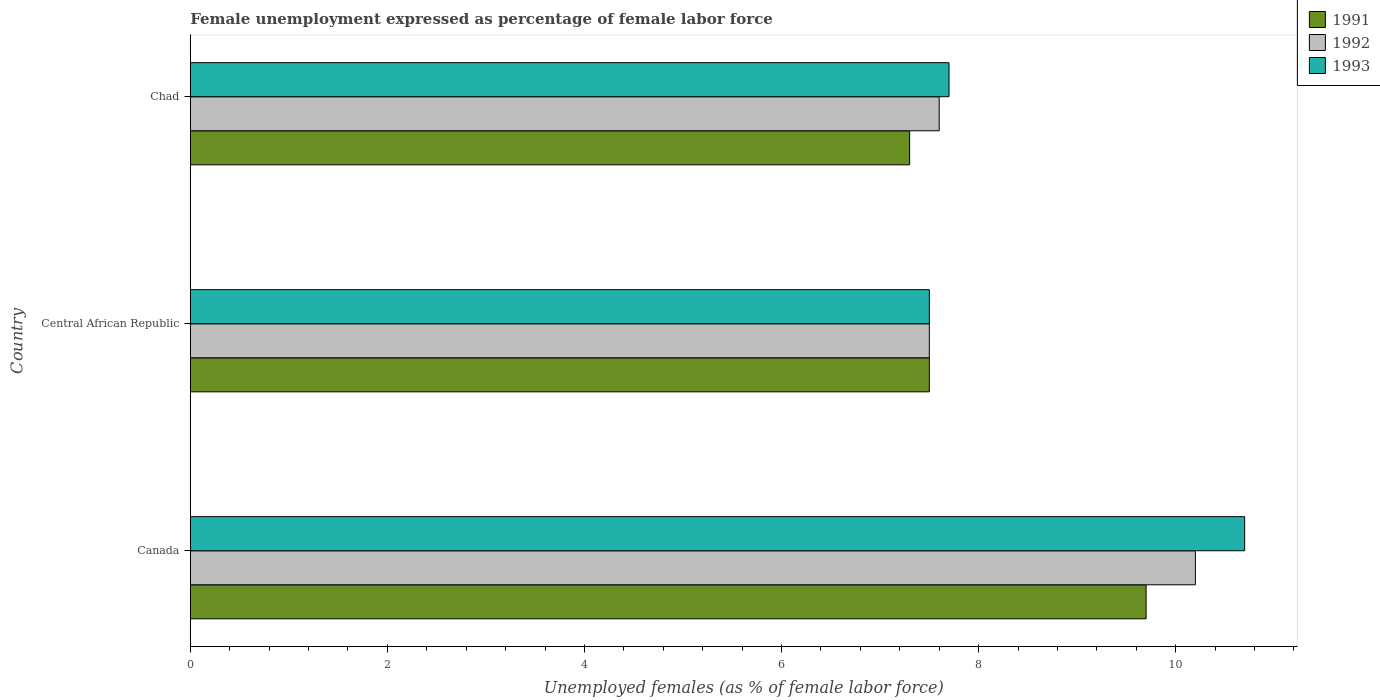How many groups of bars are there?
Give a very brief answer. 3. In how many cases, is the number of bars for a given country not equal to the number of legend labels?
Your response must be concise. 0. What is the unemployment in females in in 1993 in Central African Republic?
Your response must be concise. 7.5. Across all countries, what is the maximum unemployment in females in in 1993?
Provide a succinct answer. 10.7. In which country was the unemployment in females in in 1993 maximum?
Offer a terse response. Canada. In which country was the unemployment in females in in 1991 minimum?
Make the answer very short. Chad. What is the total unemployment in females in in 1993 in the graph?
Your response must be concise. 25.9. What is the difference between the unemployment in females in in 1993 in Central African Republic and that in Chad?
Make the answer very short. -0.2. What is the difference between the unemployment in females in in 1993 in Canada and the unemployment in females in in 1992 in Chad?
Your answer should be very brief. 3.1. What is the average unemployment in females in in 1992 per country?
Give a very brief answer. 8.43. What is the difference between the unemployment in females in in 1993 and unemployment in females in in 1992 in Canada?
Your answer should be very brief. 0.5. What is the ratio of the unemployment in females in in 1993 in Canada to that in Central African Republic?
Give a very brief answer. 1.43. Is the unemployment in females in in 1993 in Canada less than that in Central African Republic?
Provide a short and direct response. No. What is the difference between the highest and the second highest unemployment in females in in 1991?
Your answer should be very brief. 2.2. What is the difference between the highest and the lowest unemployment in females in in 1993?
Your response must be concise. 3.2. In how many countries, is the unemployment in females in in 1993 greater than the average unemployment in females in in 1993 taken over all countries?
Provide a short and direct response. 1. Is the sum of the unemployment in females in in 1993 in Central African Republic and Chad greater than the maximum unemployment in females in in 1991 across all countries?
Make the answer very short. Yes. What does the 1st bar from the top in Central African Republic represents?
Ensure brevity in your answer.  1993. What is the difference between two consecutive major ticks on the X-axis?
Keep it short and to the point. 2. Does the graph contain any zero values?
Keep it short and to the point. No. How are the legend labels stacked?
Give a very brief answer. Vertical. What is the title of the graph?
Your response must be concise. Female unemployment expressed as percentage of female labor force. What is the label or title of the X-axis?
Offer a very short reply. Unemployed females (as % of female labor force). What is the Unemployed females (as % of female labor force) of 1991 in Canada?
Make the answer very short. 9.7. What is the Unemployed females (as % of female labor force) in 1992 in Canada?
Provide a succinct answer. 10.2. What is the Unemployed females (as % of female labor force) in 1993 in Canada?
Ensure brevity in your answer.  10.7. What is the Unemployed females (as % of female labor force) in 1991 in Central African Republic?
Provide a short and direct response. 7.5. What is the Unemployed females (as % of female labor force) in 1992 in Central African Republic?
Offer a very short reply. 7.5. What is the Unemployed females (as % of female labor force) in 1993 in Central African Republic?
Provide a short and direct response. 7.5. What is the Unemployed females (as % of female labor force) in 1991 in Chad?
Ensure brevity in your answer.  7.3. What is the Unemployed females (as % of female labor force) in 1992 in Chad?
Offer a very short reply. 7.6. What is the Unemployed females (as % of female labor force) of 1993 in Chad?
Offer a terse response. 7.7. Across all countries, what is the maximum Unemployed females (as % of female labor force) of 1991?
Offer a very short reply. 9.7. Across all countries, what is the maximum Unemployed females (as % of female labor force) in 1992?
Your answer should be very brief. 10.2. Across all countries, what is the maximum Unemployed females (as % of female labor force) in 1993?
Ensure brevity in your answer.  10.7. Across all countries, what is the minimum Unemployed females (as % of female labor force) in 1991?
Keep it short and to the point. 7.3. What is the total Unemployed females (as % of female labor force) of 1992 in the graph?
Your response must be concise. 25.3. What is the total Unemployed females (as % of female labor force) of 1993 in the graph?
Keep it short and to the point. 25.9. What is the difference between the Unemployed females (as % of female labor force) of 1991 in Canada and that in Central African Republic?
Provide a succinct answer. 2.2. What is the difference between the Unemployed females (as % of female labor force) in 1992 in Canada and that in Chad?
Give a very brief answer. 2.6. What is the difference between the Unemployed females (as % of female labor force) of 1992 in Central African Republic and that in Chad?
Offer a very short reply. -0.1. What is the difference between the Unemployed females (as % of female labor force) in 1993 in Central African Republic and that in Chad?
Ensure brevity in your answer.  -0.2. What is the difference between the Unemployed females (as % of female labor force) in 1992 in Canada and the Unemployed females (as % of female labor force) in 1993 in Central African Republic?
Your response must be concise. 2.7. What is the difference between the Unemployed females (as % of female labor force) in 1991 in Canada and the Unemployed females (as % of female labor force) in 1992 in Chad?
Provide a short and direct response. 2.1. What is the difference between the Unemployed females (as % of female labor force) in 1991 in Canada and the Unemployed females (as % of female labor force) in 1993 in Chad?
Give a very brief answer. 2. What is the difference between the Unemployed females (as % of female labor force) of 1992 in Canada and the Unemployed females (as % of female labor force) of 1993 in Chad?
Keep it short and to the point. 2.5. What is the difference between the Unemployed females (as % of female labor force) of 1991 in Central African Republic and the Unemployed females (as % of female labor force) of 1992 in Chad?
Your response must be concise. -0.1. What is the average Unemployed females (as % of female labor force) of 1991 per country?
Ensure brevity in your answer.  8.17. What is the average Unemployed females (as % of female labor force) in 1992 per country?
Your response must be concise. 8.43. What is the average Unemployed females (as % of female labor force) of 1993 per country?
Offer a very short reply. 8.63. What is the difference between the Unemployed females (as % of female labor force) in 1992 and Unemployed females (as % of female labor force) in 1993 in Canada?
Keep it short and to the point. -0.5. What is the difference between the Unemployed females (as % of female labor force) of 1991 and Unemployed females (as % of female labor force) of 1993 in Central African Republic?
Provide a succinct answer. 0. What is the difference between the Unemployed females (as % of female labor force) of 1992 and Unemployed females (as % of female labor force) of 1993 in Central African Republic?
Give a very brief answer. 0. What is the difference between the Unemployed females (as % of female labor force) in 1991 and Unemployed females (as % of female labor force) in 1992 in Chad?
Make the answer very short. -0.3. What is the difference between the Unemployed females (as % of female labor force) in 1991 and Unemployed females (as % of female labor force) in 1993 in Chad?
Keep it short and to the point. -0.4. What is the difference between the Unemployed females (as % of female labor force) in 1992 and Unemployed females (as % of female labor force) in 1993 in Chad?
Make the answer very short. -0.1. What is the ratio of the Unemployed females (as % of female labor force) of 1991 in Canada to that in Central African Republic?
Your answer should be very brief. 1.29. What is the ratio of the Unemployed females (as % of female labor force) of 1992 in Canada to that in Central African Republic?
Your answer should be very brief. 1.36. What is the ratio of the Unemployed females (as % of female labor force) of 1993 in Canada to that in Central African Republic?
Ensure brevity in your answer.  1.43. What is the ratio of the Unemployed females (as % of female labor force) in 1991 in Canada to that in Chad?
Provide a short and direct response. 1.33. What is the ratio of the Unemployed females (as % of female labor force) of 1992 in Canada to that in Chad?
Give a very brief answer. 1.34. What is the ratio of the Unemployed females (as % of female labor force) of 1993 in Canada to that in Chad?
Make the answer very short. 1.39. What is the ratio of the Unemployed females (as % of female labor force) in 1991 in Central African Republic to that in Chad?
Ensure brevity in your answer.  1.03. What is the ratio of the Unemployed females (as % of female labor force) of 1992 in Central African Republic to that in Chad?
Provide a succinct answer. 0.99. What is the difference between the highest and the second highest Unemployed females (as % of female labor force) of 1992?
Your answer should be compact. 2.6. What is the difference between the highest and the second highest Unemployed females (as % of female labor force) in 1993?
Your answer should be compact. 3. 